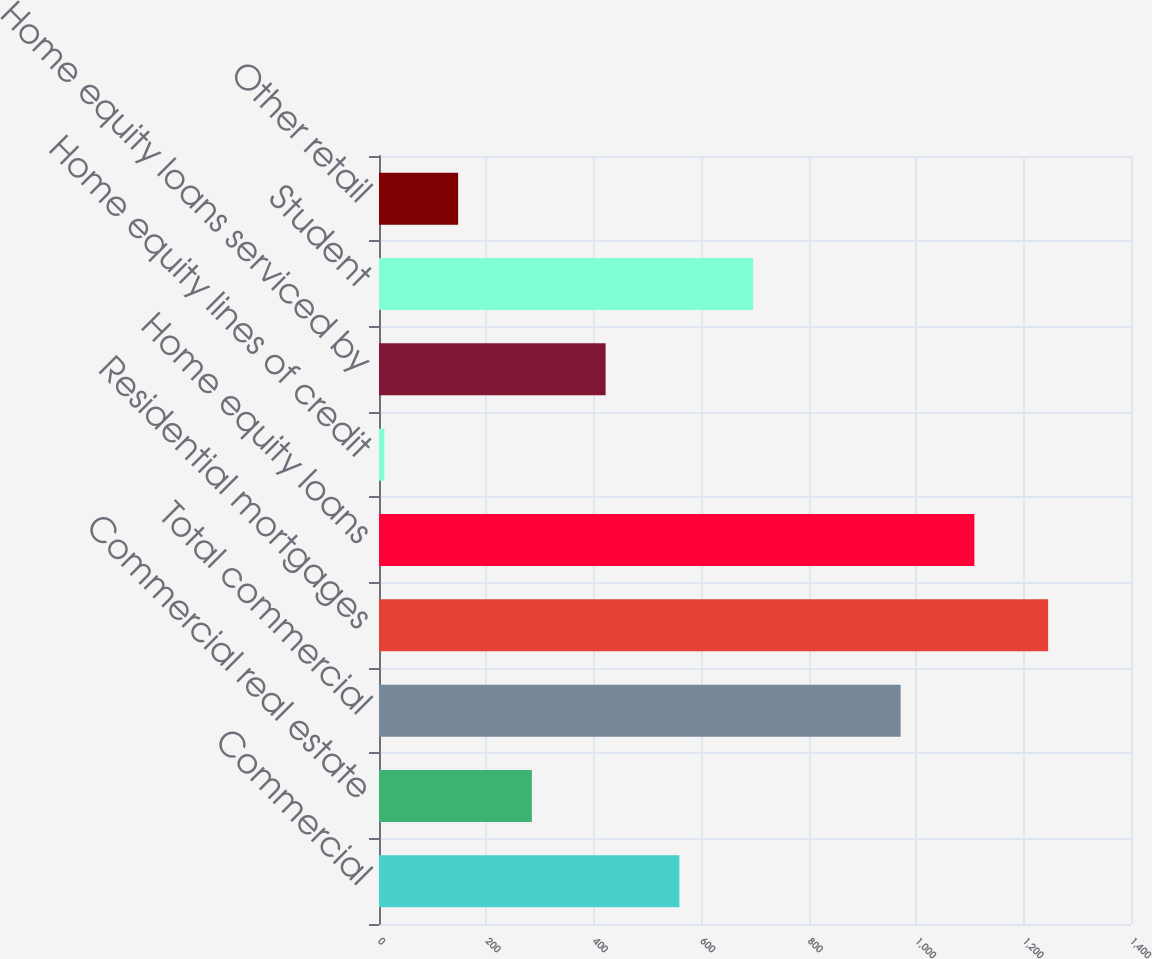<chart> <loc_0><loc_0><loc_500><loc_500><bar_chart><fcel>Commercial<fcel>Commercial real estate<fcel>Total commercial<fcel>Residential mortgages<fcel>Home equity loans<fcel>Home equity lines of credit<fcel>Home equity loans serviced by<fcel>Student<fcel>Other retail<nl><fcel>559.2<fcel>284.6<fcel>971.1<fcel>1245.7<fcel>1108.4<fcel>10<fcel>421.9<fcel>696.5<fcel>147.3<nl></chart> 